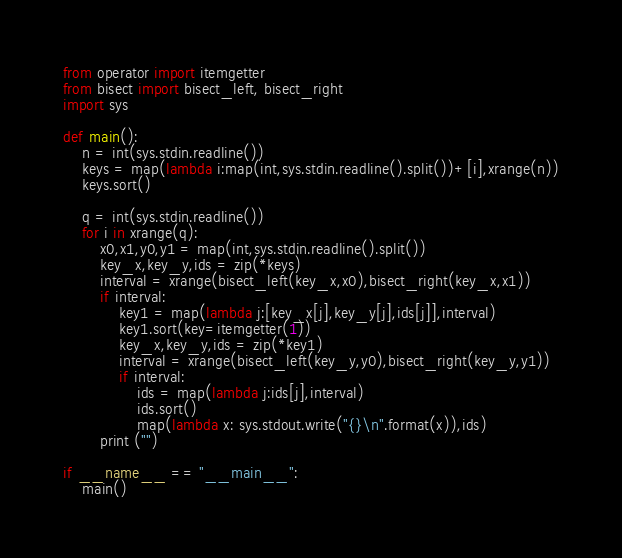Convert code to text. <code><loc_0><loc_0><loc_500><loc_500><_Python_>from operator import itemgetter
from bisect import bisect_left, bisect_right
import sys

def main():
    n = int(sys.stdin.readline())
    keys = map(lambda i:map(int,sys.stdin.readline().split())+[i],xrange(n))
    keys.sort()

    q = int(sys.stdin.readline())
    for i in xrange(q):
        x0,x1,y0,y1 = map(int,sys.stdin.readline().split())
        key_x,key_y,ids = zip(*keys)
        interval = xrange(bisect_left(key_x,x0),bisect_right(key_x,x1))
        if interval:
            key1 = map(lambda j:[key_x[j],key_y[j],ids[j]],interval)
            key1.sort(key=itemgetter(1))
            key_x,key_y,ids = zip(*key1)
            interval = xrange(bisect_left(key_y,y0),bisect_right(key_y,y1))
            if interval:
                ids = map(lambda j:ids[j],interval)
                ids.sort()
                map(lambda x: sys.stdout.write("{}\n".format(x)),ids)
        print ("")

if __name__ == "__main__":
    main()</code> 